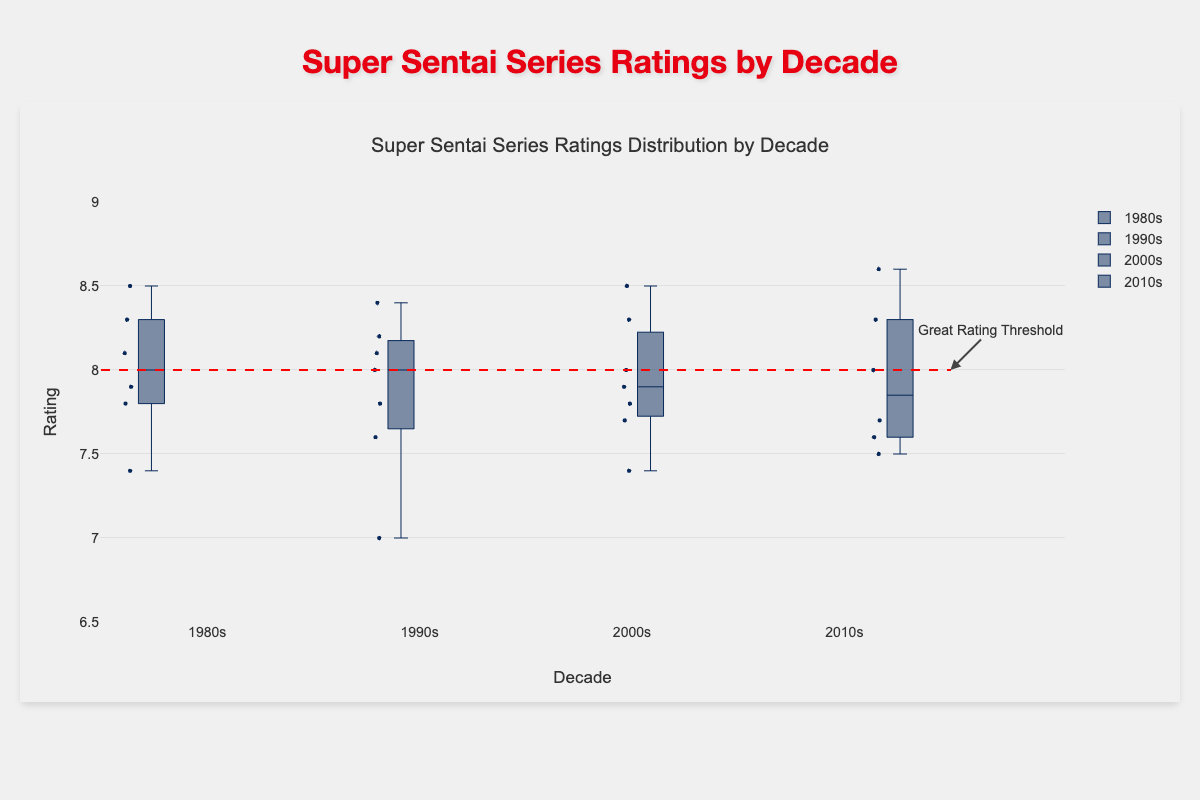What is the median rating for the 2010s decade? The box plot's middle line represents the median rating. Look at the box plot for the 2010s decade to find the middle line's value.
Answer: 8.0 Which decade has the widest range of ratings? The range is the difference between the maximum and minimum values in the box plot. Comparing the box plots for each decade, the decade with the longest vertical span has the widest range.
Answer: 1980s What is the highest rating recorded, and in which decade does it appear? The highest rating is the topmost point on the highest box plot. Look at the outliers and top whiskers of each decade's box plots to determine the highest point.
Answer: 8.6 in 2010s (Kaizoku Sentai Gokaiger) Which decade has the lowest median rating? The median is the middle line within each box plot. Identify which decade has the lowest such line.
Answer: 1990s Compare the interquartile range (IQR) of ratings between the 1980s and the 2000s. Which decade has the larger IQR? The IQR is the range between the first quartile (bottom of the box) and the third quartile (top of the box). Visually compare the heights of the boxes from 1980s and 2000s.
Answer: 2000s How many series in the 2000s have ratings above 8.0? Box plot points above the 8.0 rating mark, particularly those labeled as outliers or in the upper quartile. Count these points in the 2000s box plot.
Answer: 3 Which decade has the most series with a rating of 7.5 or lower? Observe the points and whiskers below the 7.5 ratings line for each decade's box plot and count the number of series in each.
Answer: 1990s What is the mean rating for the 1980s? Calculate the arithmetic mean by summing all ratings for the 1980s and dividing by the number of series. Verify calculation specifics if needed. (8.1+7.8+8.5+7.9+8.3+7.4)/6 = 7.83
Answer: 7.83 Which series has the lowest rating in the 1990s, and what is its rating? Identify the lowest point in the 1990s box plot, using hover text if visible, which should show the series name and rating.
Answer: Chikyuu Sentai Fiveman with a rating of 7.0 